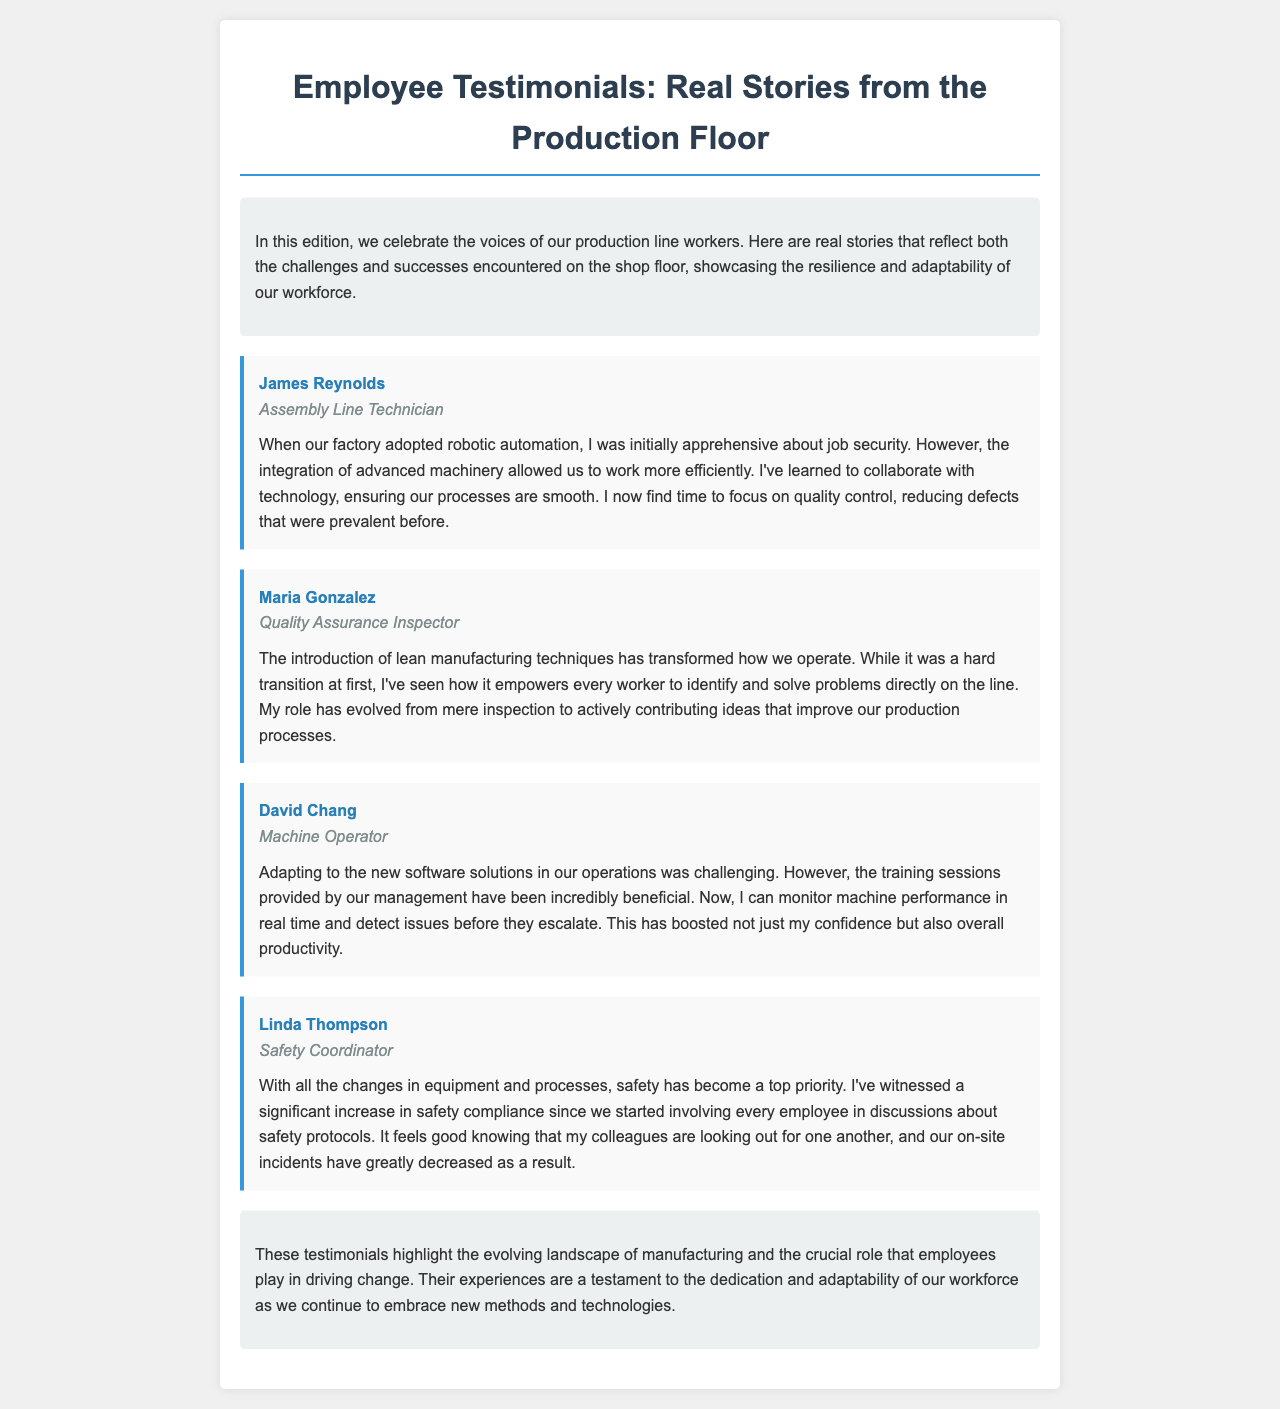What is the title of the newsletter? The title of the newsletter is presented at the top of the document, which is "Employee Testimonials: Real Stories from the Production Floor."
Answer: Employee Testimonials: Real Stories from the Production Floor Who is the Assembly Line Technician? The document lists James Reynolds as the individual holding this position, along with his testimonial.
Answer: James Reynolds What manufacturing technique did Maria Gonzalez mention? In her story, Maria highlights the introduction of lean manufacturing techniques as a key change in their operations.
Answer: Lean manufacturing techniques How has David Chang's role changed? David mentions that his role has evolved to include monitoring machine performance in real time, which adds a layer of responsibilities beyond operating the machines.
Answer: Monitoring machine performance What has increased due to employee involvement in safety discussions? Linda Thompson's testimony indicates that safety compliance has significantly increased since they began involving employees in discussions about safety protocols.
Answer: Safety compliance What challenge did David Chang face? David notes that adapting to new software solutions was a significant challenge for him and others in the production line.
Answer: Adapting to new software solutions What is a major benefit James Reynolds finds in working with technology? He highlights that working with technology has allowed him to focus more on quality control, minimizing defects in the production process.
Answer: Quality control What improved as a result of the changes in processes, according to Linda Thompson? Linda states that the on-site incidents related to safety have greatly decreased due to improvements made in processes and employee engagement.
Answer: On-site incidents have greatly decreased 